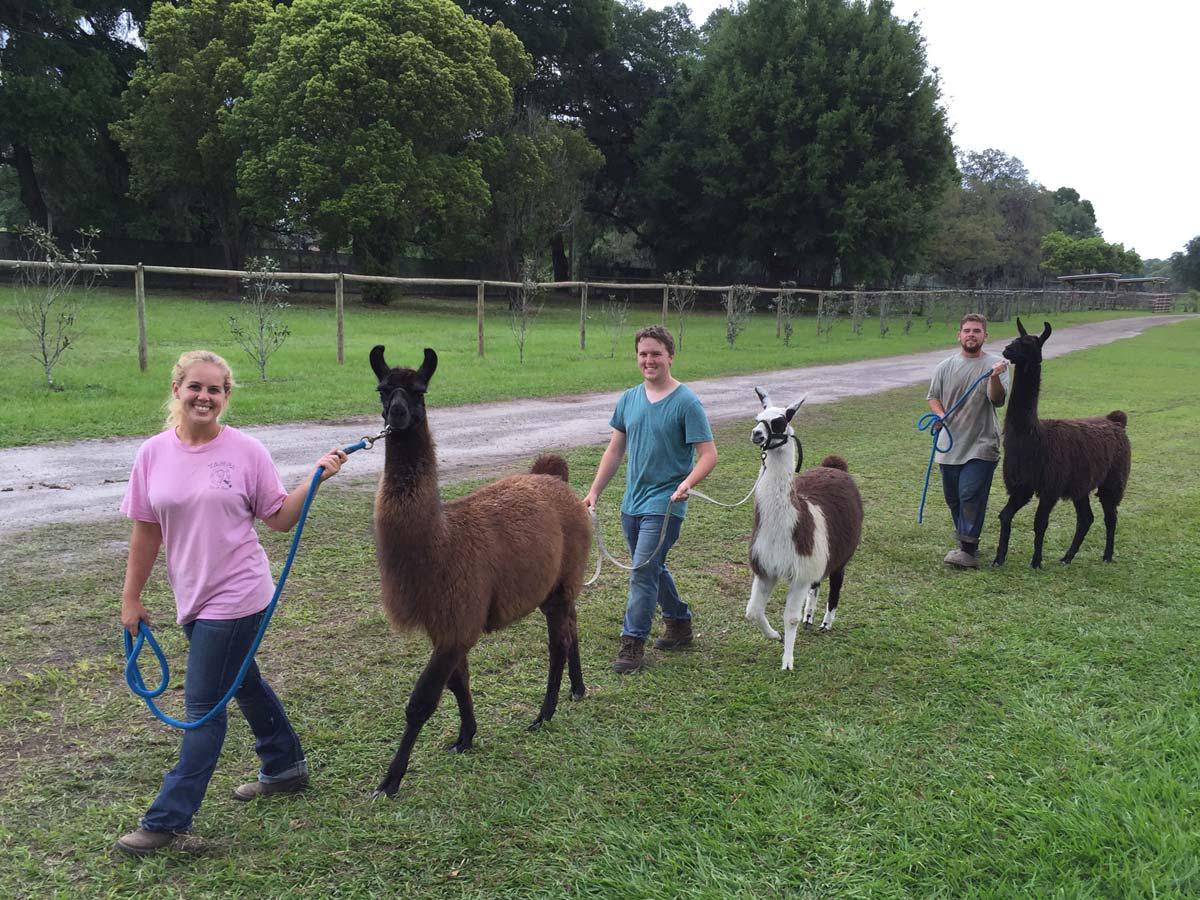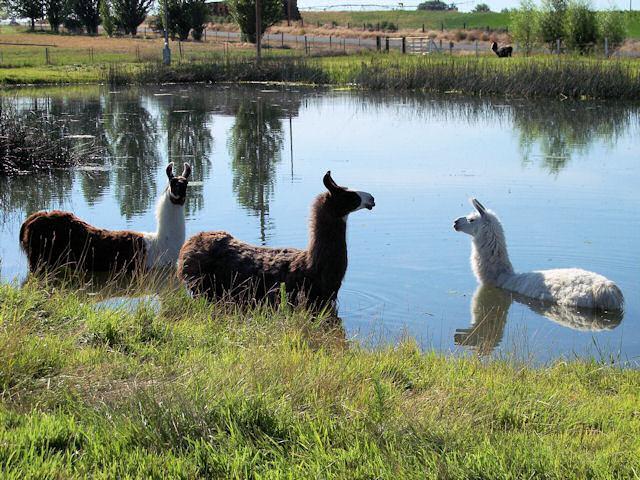The first image is the image on the left, the second image is the image on the right. Considering the images on both sides, is "A forward-turned llama is behind a blue swimming pool in the lefthand image." valid? Answer yes or no. No. The first image is the image on the left, the second image is the image on the right. Assess this claim about the two images: "The left image contains no more than one llama.". Correct or not? Answer yes or no. No. 